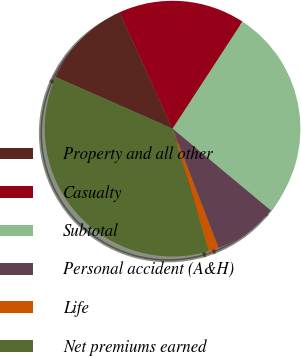Convert chart to OTSL. <chart><loc_0><loc_0><loc_500><loc_500><pie_chart><fcel>Property and all other<fcel>Casualty<fcel>Subtotal<fcel>Personal accident (A&H)<fcel>Life<fcel>Net premiums earned<nl><fcel>11.58%<fcel>16.01%<fcel>26.85%<fcel>8.09%<fcel>1.27%<fcel>36.21%<nl></chart> 